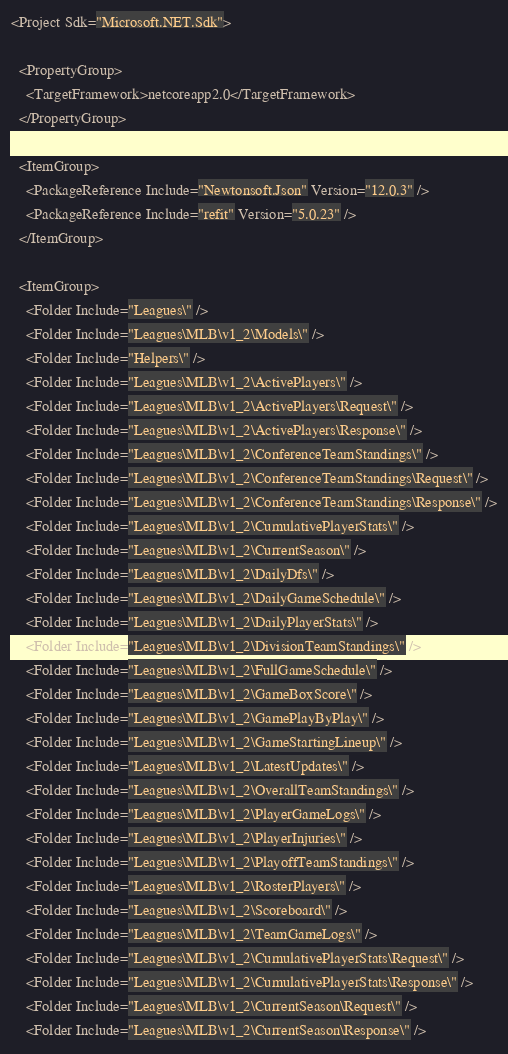Convert code to text. <code><loc_0><loc_0><loc_500><loc_500><_XML_><Project Sdk="Microsoft.NET.Sdk">

  <PropertyGroup>
    <TargetFramework>netcoreapp2.0</TargetFramework>
  </PropertyGroup>

  <ItemGroup>
    <PackageReference Include="Newtonsoft.Json" Version="12.0.3" />
    <PackageReference Include="refit" Version="5.0.23" />
  </ItemGroup>

  <ItemGroup>
    <Folder Include="Leagues\" />
    <Folder Include="Leagues\MLB\v1_2\Models\" />
    <Folder Include="Helpers\" />
    <Folder Include="Leagues\MLB\v1_2\ActivePlayers\" />
    <Folder Include="Leagues\MLB\v1_2\ActivePlayers\Request\" />
    <Folder Include="Leagues\MLB\v1_2\ActivePlayers\Response\" />
    <Folder Include="Leagues\MLB\v1_2\ConferenceTeamStandings\" />
    <Folder Include="Leagues\MLB\v1_2\ConferenceTeamStandings\Request\" />
    <Folder Include="Leagues\MLB\v1_2\ConferenceTeamStandings\Response\" />
    <Folder Include="Leagues\MLB\v1_2\CumulativePlayerStats\" />
    <Folder Include="Leagues\MLB\v1_2\CurrentSeason\" />
    <Folder Include="Leagues\MLB\v1_2\DailyDfs\" />
    <Folder Include="Leagues\MLB\v1_2\DailyGameSchedule\" />
    <Folder Include="Leagues\MLB\v1_2\DailyPlayerStats\" />
    <Folder Include="Leagues\MLB\v1_2\DivisionTeamStandings\" />
    <Folder Include="Leagues\MLB\v1_2\FullGameSchedule\" />
    <Folder Include="Leagues\MLB\v1_2\GameBoxScore\" />
    <Folder Include="Leagues\MLB\v1_2\GamePlayByPlay\" />
    <Folder Include="Leagues\MLB\v1_2\GameStartingLineup\" />
    <Folder Include="Leagues\MLB\v1_2\LatestUpdates\" />
    <Folder Include="Leagues\MLB\v1_2\OverallTeamStandings\" />
    <Folder Include="Leagues\MLB\v1_2\PlayerGameLogs\" />
    <Folder Include="Leagues\MLB\v1_2\PlayerInjuries\" />
    <Folder Include="Leagues\MLB\v1_2\PlayoffTeamStandings\" />
    <Folder Include="Leagues\MLB\v1_2\RosterPlayers\" />
    <Folder Include="Leagues\MLB\v1_2\Scoreboard\" />
    <Folder Include="Leagues\MLB\v1_2\TeamGameLogs\" />
    <Folder Include="Leagues\MLB\v1_2\CumulativePlayerStats\Request\" />
    <Folder Include="Leagues\MLB\v1_2\CumulativePlayerStats\Response\" />
    <Folder Include="Leagues\MLB\v1_2\CurrentSeason\Request\" />
    <Folder Include="Leagues\MLB\v1_2\CurrentSeason\Response\" /></code> 